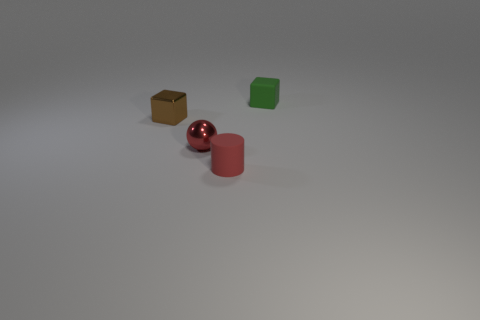Add 3 metal cubes. How many objects exist? 7 Subtract all spheres. How many objects are left? 3 Subtract all brown metallic cubes. Subtract all tiny blue metallic objects. How many objects are left? 3 Add 4 rubber objects. How many rubber objects are left? 6 Add 1 small red cylinders. How many small red cylinders exist? 2 Subtract 0 gray balls. How many objects are left? 4 